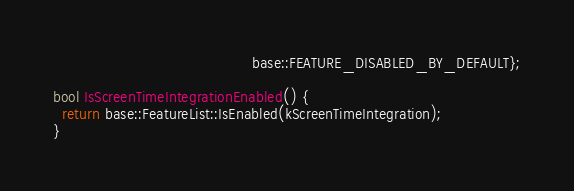Convert code to text. <code><loc_0><loc_0><loc_500><loc_500><_ObjectiveC_>                                           base::FEATURE_DISABLED_BY_DEFAULT};

bool IsScreenTimeIntegrationEnabled() {
  return base::FeatureList::IsEnabled(kScreenTimeIntegration);
}
</code> 